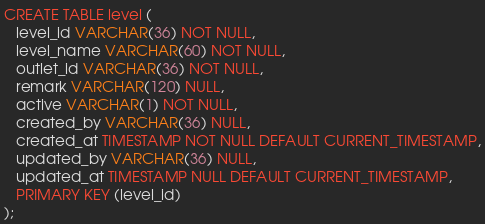<code> <loc_0><loc_0><loc_500><loc_500><_SQL_>CREATE TABLE level (
   level_id VARCHAR(36) NOT NULL,
   level_name VARCHAR(60) NOT NULL,
   outlet_id VARCHAR(36) NOT NULL,
   remark VARCHAR(120) NULL,
   active VARCHAR(1) NOT NULL,
   created_by VARCHAR(36) NULL,
   created_at TIMESTAMP NOT NULL DEFAULT CURRENT_TIMESTAMP,
   updated_by VARCHAR(36) NULL,
   updated_at TIMESTAMP NULL DEFAULT CURRENT_TIMESTAMP,
   PRIMARY KEY (level_id)
);</code> 